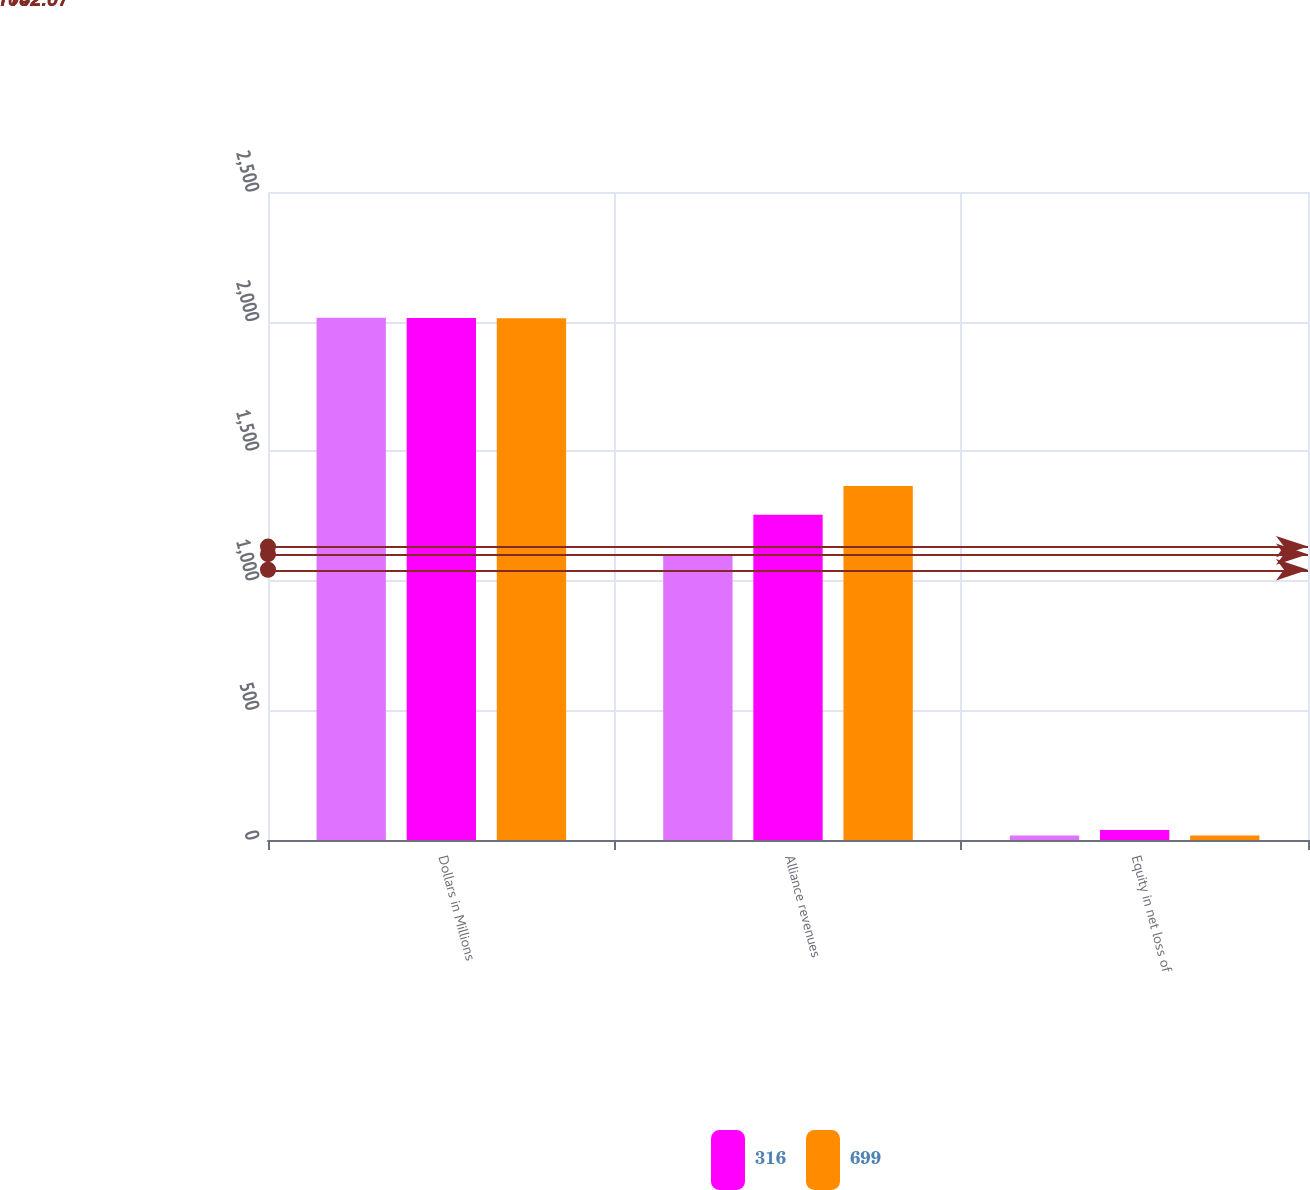<chart> <loc_0><loc_0><loc_500><loc_500><stacked_bar_chart><ecel><fcel>Dollars in Millions<fcel>Alliance revenues<fcel>Equity in net loss of<nl><fcel>nan<fcel>2015<fcel>1096<fcel>17<nl><fcel>316<fcel>2014<fcel>1255<fcel>39<nl><fcel>699<fcel>2013<fcel>1366<fcel>17<nl></chart> 